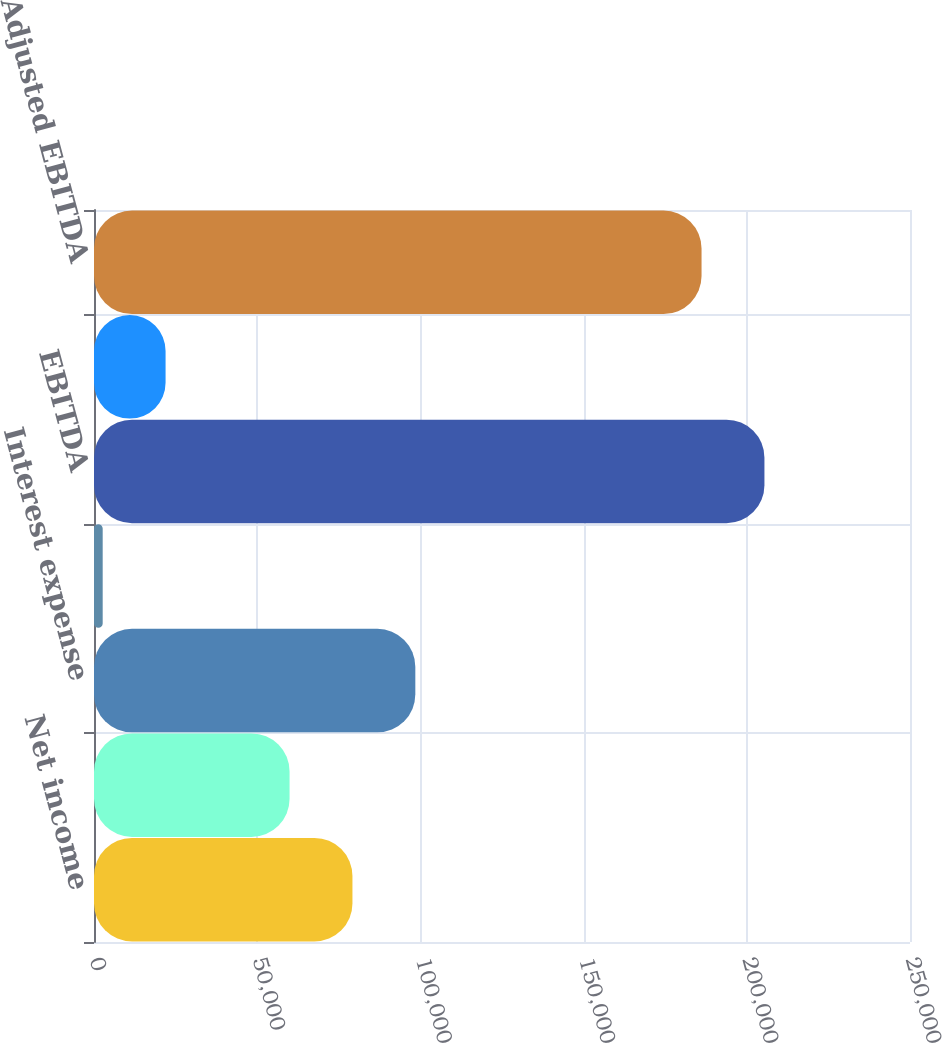<chart> <loc_0><loc_0><loc_500><loc_500><bar_chart><fcel>Net income<fcel>Depreciation and amortization<fcel>Interest expense<fcel>Other interest income<fcel>EBITDA<fcel>Gain loss on sale of real<fcel>Adjusted EBITDA<nl><fcel>79179.9<fcel>59914<fcel>98445.8<fcel>2662<fcel>205402<fcel>21927.9<fcel>186136<nl></chart> 